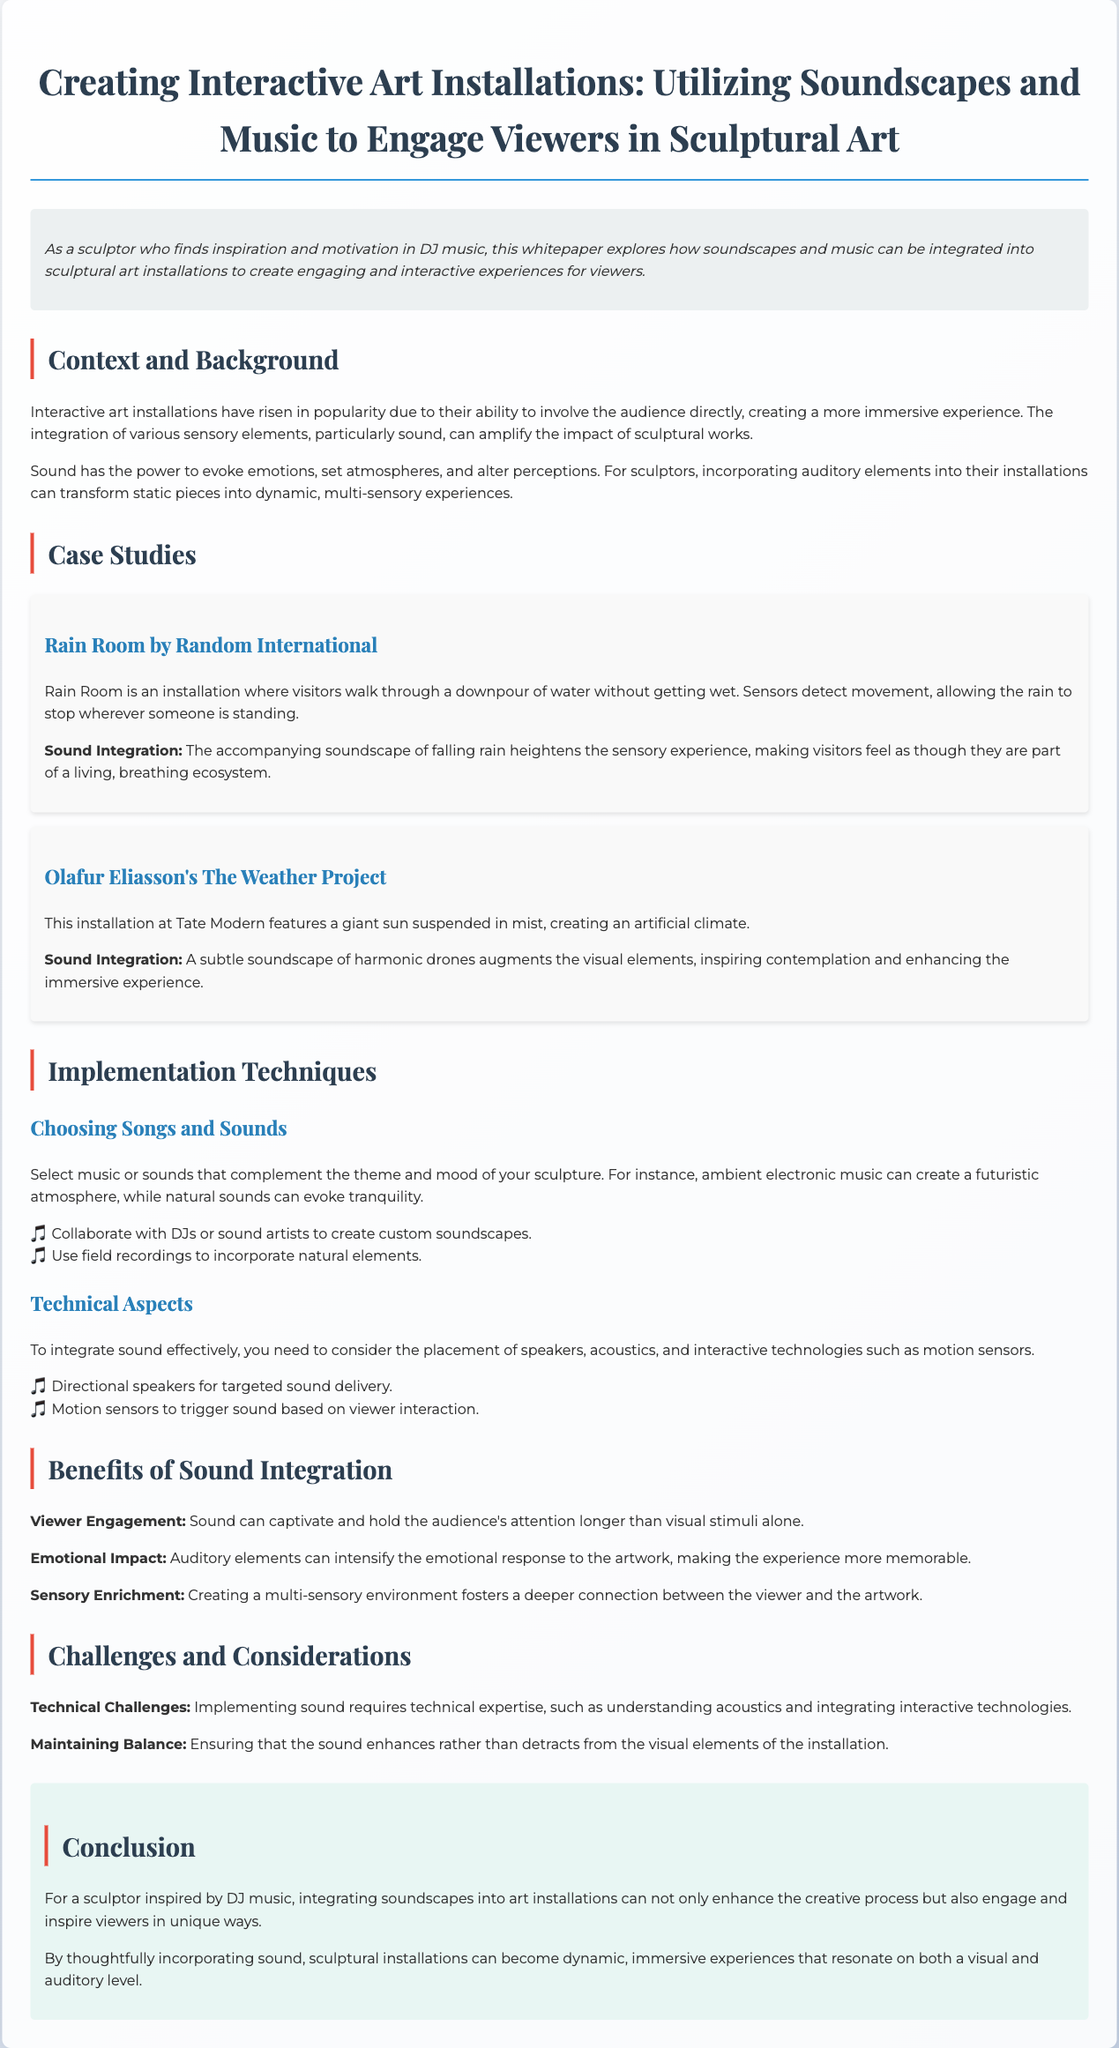what is the title of the whitepaper? The title of the whitepaper is presented clearly at the beginning of the document.
Answer: Creating Interactive Art Installations: Utilizing Soundscapes and Music to Engage Viewers in Sculptural Art who authored the case study on Rain Room? The case study details are attributed to the creators of the installation, mentioned in the text.
Answer: Random International what is one emotional impact of sound integration mentioned? The document explicitly states a benefit of sound integration that relates to emotions.
Answer: Emotional Impact how does sound enhance viewer engagement? The text describes sound's role in captivating the audience's attention.
Answer: Captivates attention longer what type of artists should sculptors collaborate with for soundscapes? The document suggests a specific type of artist for collaboration to enhance the installation.
Answer: DJs or sound artists what installation features a giant sun? The document provides information about specific installations including notable features.
Answer: The Weather Project what is a technical challenge mentioned in the document? The whitepaper outlines potential challenges when integrating sound into art installations.
Answer: Technical expertise which color is associated with headers in the document? The document uses specific colors for different text elements, including headers.
Answer: #2c3e50 